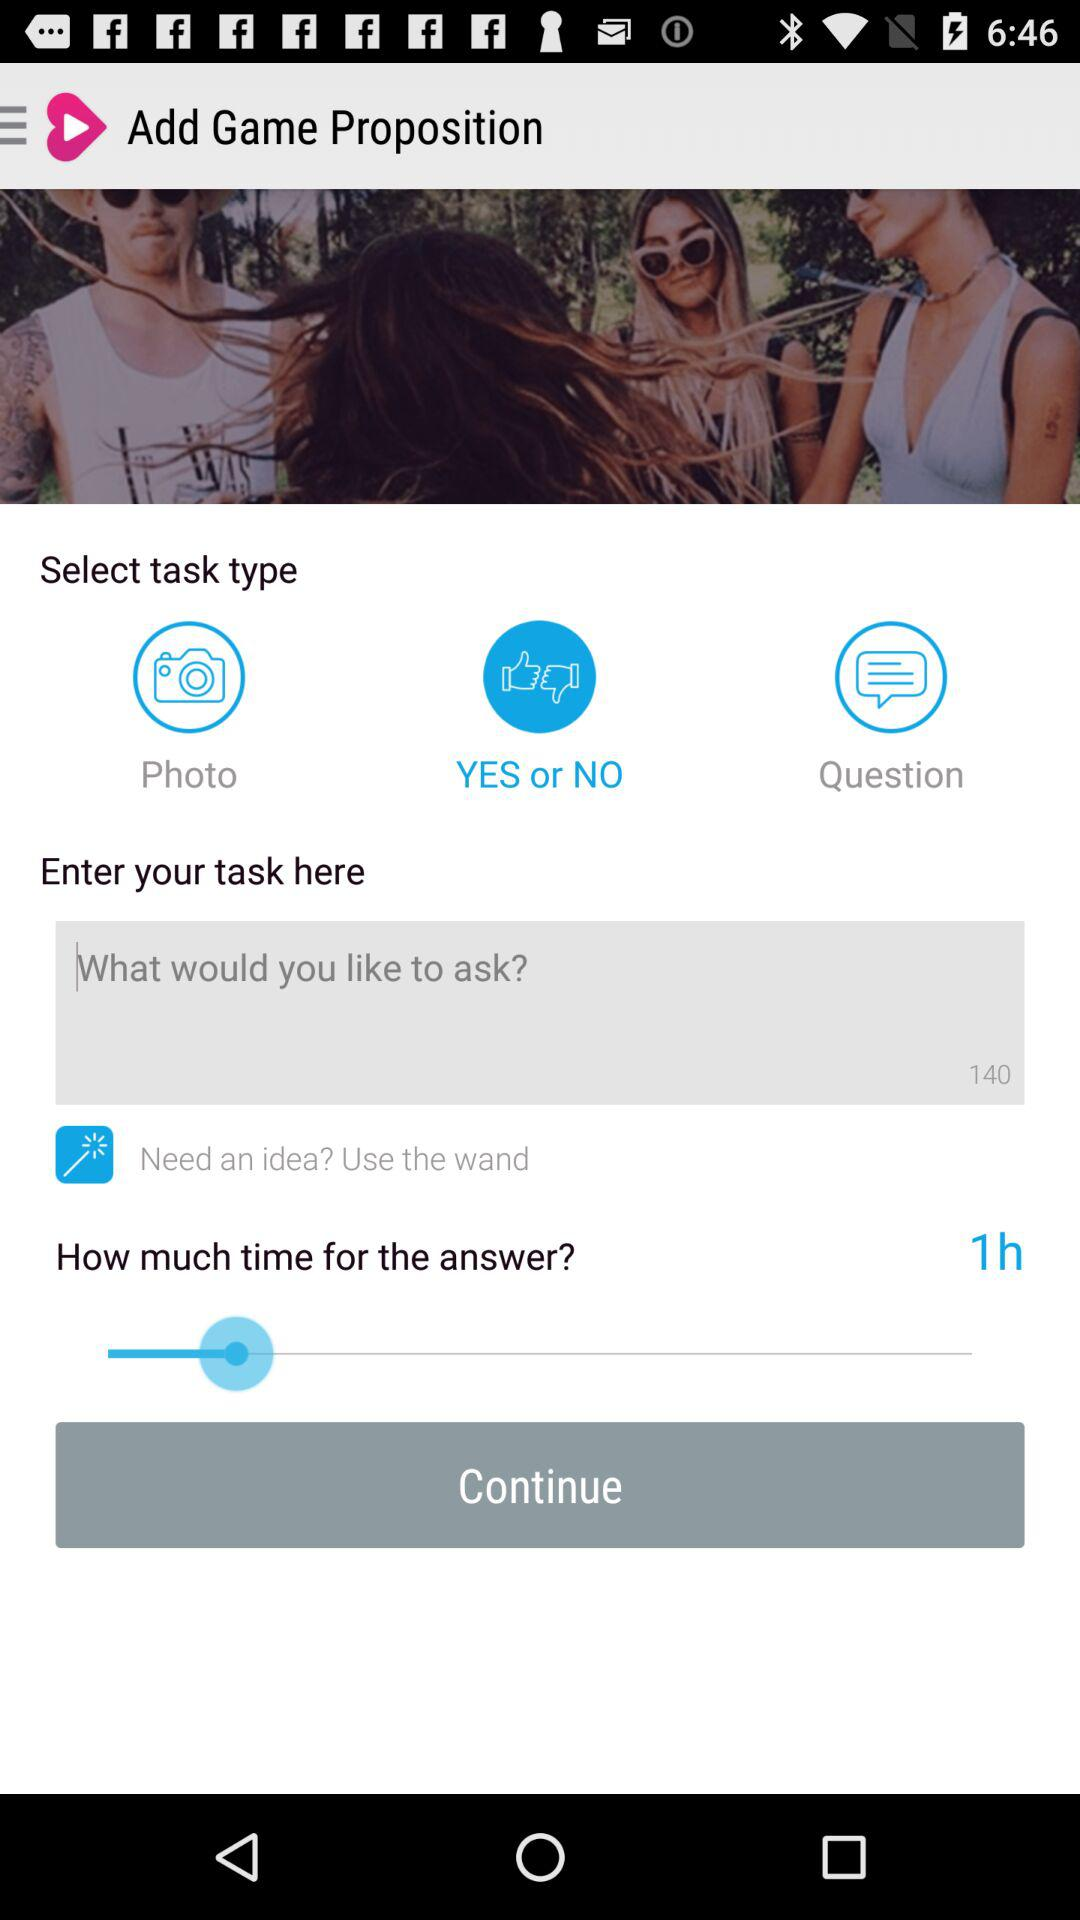How many minutes is the time limit?
Answer the question using a single word or phrase. 60 